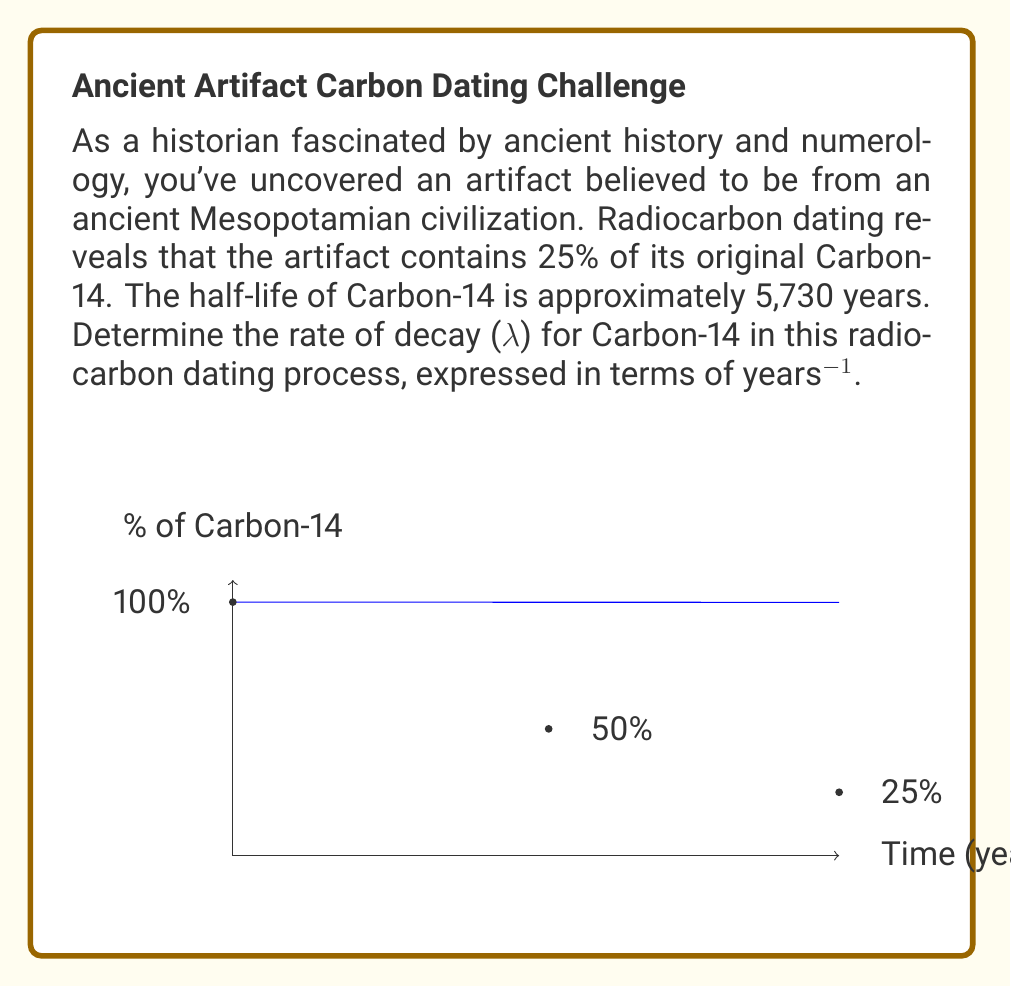What is the answer to this math problem? To solve this problem, we'll use the exponential decay formula and the given information:

1) The exponential decay formula is:
   $N(t) = N_0 e^{-λt}$
   where $N(t)$ is the amount at time $t$, $N_0$ is the initial amount, $λ$ is the decay rate, and $t$ is time.

2) We know that after one half-life (5,730 years), 50% of the original amount remains. Let's use this to find $λ$:
   $0.5 = e^{-λ(5730)}$

3) Take the natural log of both sides:
   $\ln(0.5) = -5730λ$

4) Solve for $λ$:
   $λ = -\frac{\ln(0.5)}{5730} ≈ 0.000121$ years^(-1)

5) We can verify this using the given information that 25% remains:
   $0.25 = e^{-λ(t)}$
   $\ln(0.25) = -λt$
   $t = -\frac{\ln(0.25)}{λ} ≈ 11,460$ years

   This is indeed two half-lives, confirming our calculation.
Answer: $λ ≈ 0.000121$ years^(-1) 